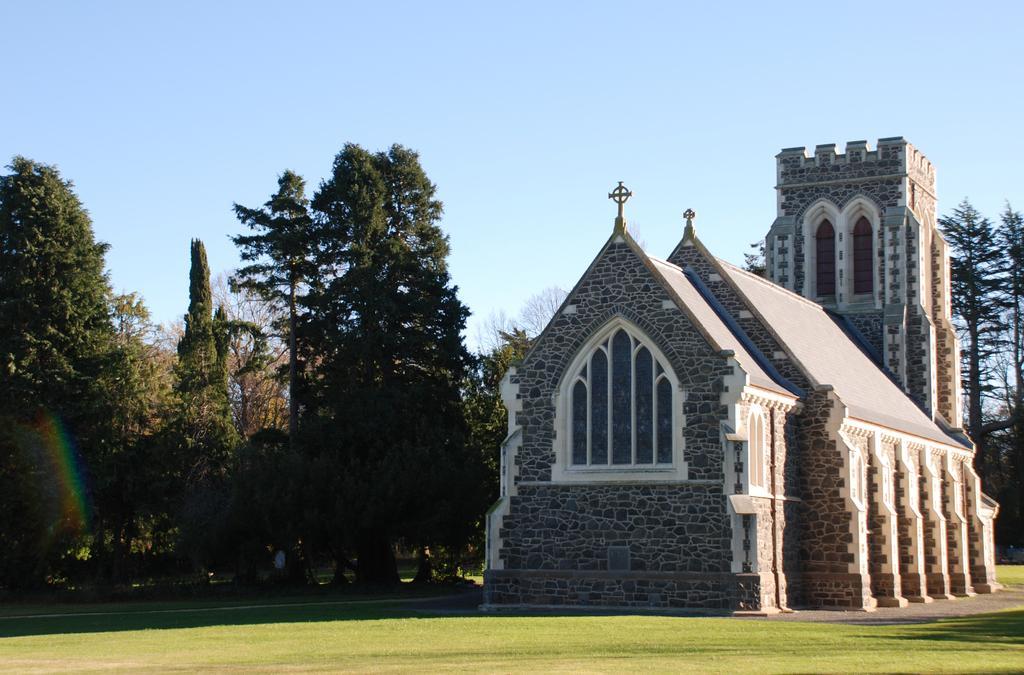How would you summarize this image in a sentence or two? In this picture it looks like a church on the right side. In the middle I can see few trees, at the top there is the sky. 